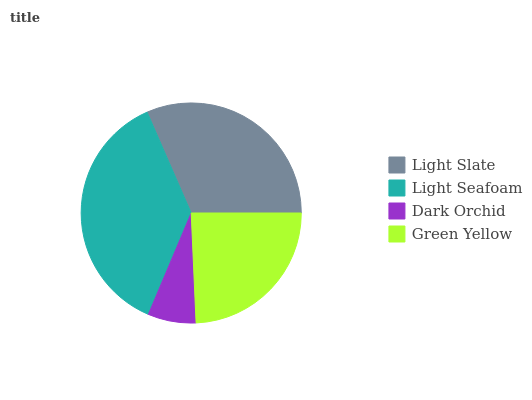Is Dark Orchid the minimum?
Answer yes or no. Yes. Is Light Seafoam the maximum?
Answer yes or no. Yes. Is Light Seafoam the minimum?
Answer yes or no. No. Is Dark Orchid the maximum?
Answer yes or no. No. Is Light Seafoam greater than Dark Orchid?
Answer yes or no. Yes. Is Dark Orchid less than Light Seafoam?
Answer yes or no. Yes. Is Dark Orchid greater than Light Seafoam?
Answer yes or no. No. Is Light Seafoam less than Dark Orchid?
Answer yes or no. No. Is Light Slate the high median?
Answer yes or no. Yes. Is Green Yellow the low median?
Answer yes or no. Yes. Is Light Seafoam the high median?
Answer yes or no. No. Is Light Slate the low median?
Answer yes or no. No. 